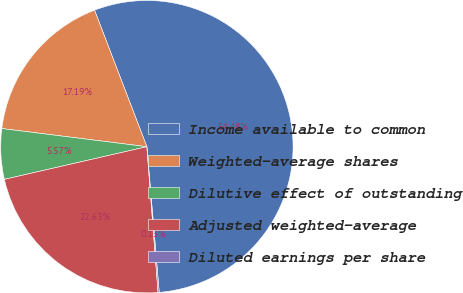Convert chart. <chart><loc_0><loc_0><loc_500><loc_500><pie_chart><fcel>Income available to common<fcel>Weighted-average shares<fcel>Dilutive effect of outstanding<fcel>Adjusted weighted-average<fcel>Diluted earnings per share<nl><fcel>54.48%<fcel>17.19%<fcel>5.57%<fcel>22.63%<fcel>0.13%<nl></chart> 